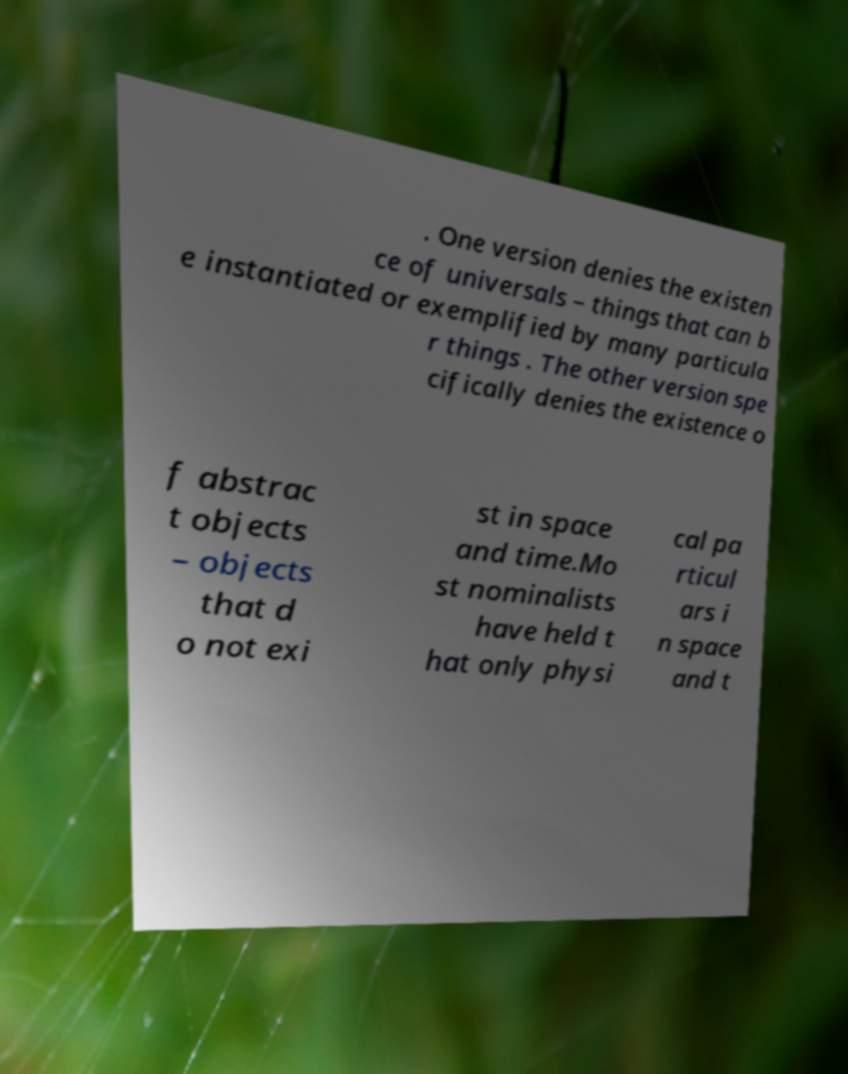What messages or text are displayed in this image? I need them in a readable, typed format. . One version denies the existen ce of universals – things that can b e instantiated or exemplified by many particula r things . The other version spe cifically denies the existence o f abstrac t objects – objects that d o not exi st in space and time.Mo st nominalists have held t hat only physi cal pa rticul ars i n space and t 